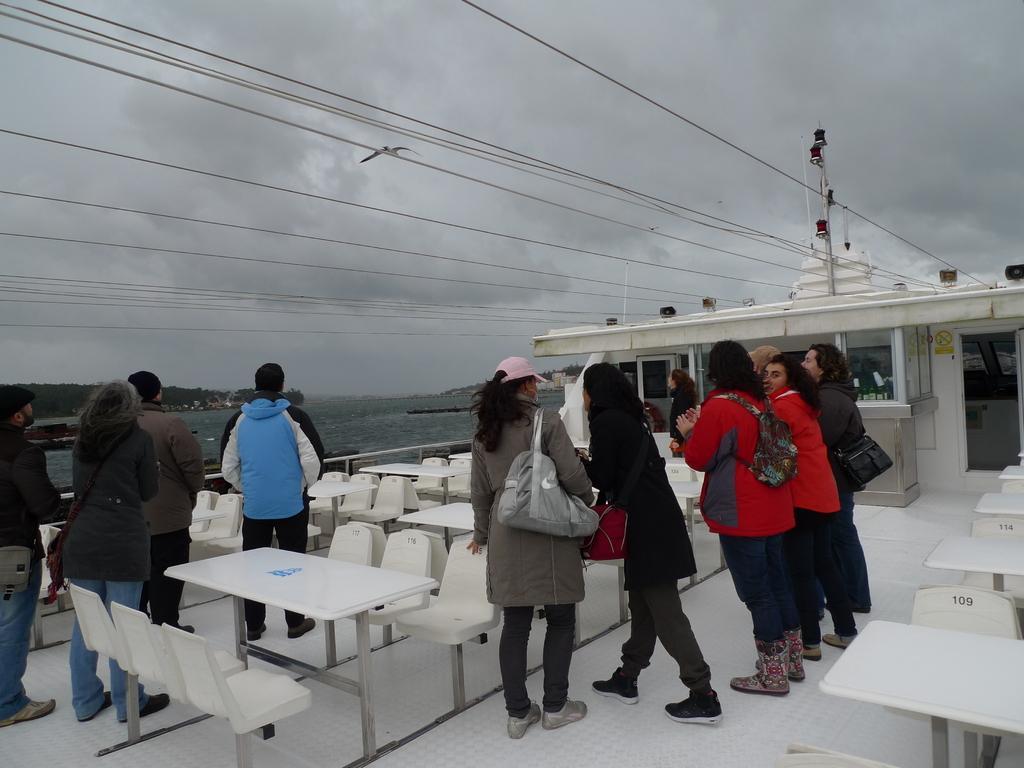How would you summarize this image in a sentence or two? In this picture we can see group of people, they are standing on the ship, and few people wore bags, beside to them we can see few chairs and benches, in the background we can find water and cables. 